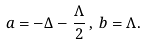<formula> <loc_0><loc_0><loc_500><loc_500>a = - \Delta - \frac { \Lambda } { 2 } \, , \, b = \Lambda .</formula> 